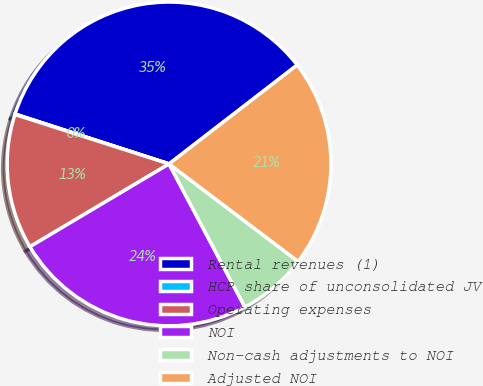Convert chart to OTSL. <chart><loc_0><loc_0><loc_500><loc_500><pie_chart><fcel>Rental revenues (1)<fcel>HCP share of unconsolidated JV<fcel>Operating expenses<fcel>NOI<fcel>Non-cash adjustments to NOI<fcel>Adjusted NOI<nl><fcel>34.55%<fcel>0.05%<fcel>13.48%<fcel>24.21%<fcel>6.95%<fcel>20.76%<nl></chart> 